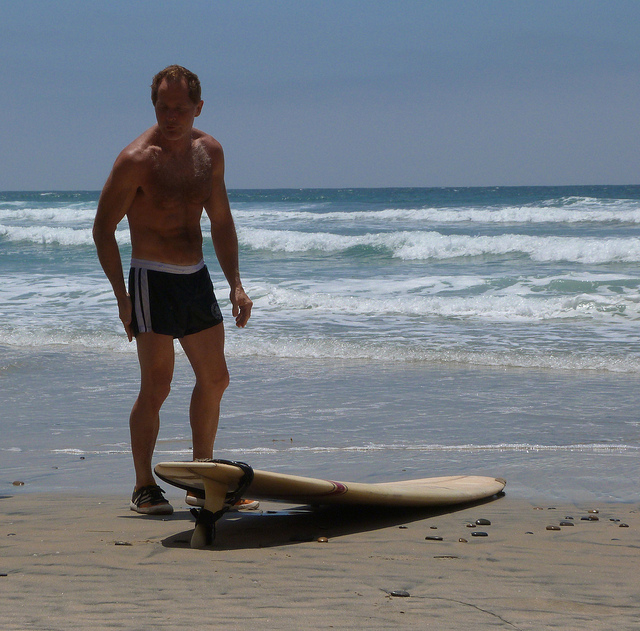What objects are prominently featured in the image? The image prominently features a man standing on the shore of a beach, with a surfboard lying next to him on the sand. The sea with moderate waves is visible in the background, adding context to the scene. 